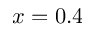<formula> <loc_0><loc_0><loc_500><loc_500>x = 0 . 4</formula> 